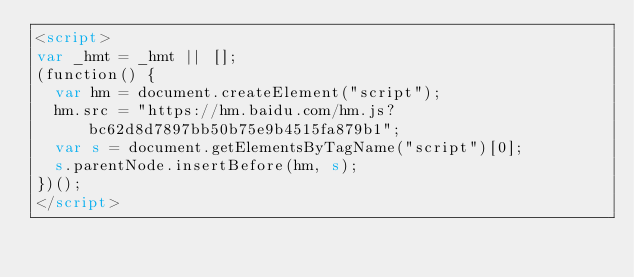Convert code to text. <code><loc_0><loc_0><loc_500><loc_500><_HTML_><script>
var _hmt = _hmt || [];
(function() {
  var hm = document.createElement("script");
  hm.src = "https://hm.baidu.com/hm.js?bc62d8d7897bb50b75e9b4515fa879b1";
  var s = document.getElementsByTagName("script")[0]; 
  s.parentNode.insertBefore(hm, s);
})();
</script>
</code> 